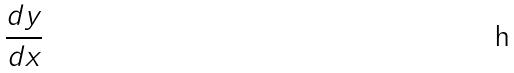<formula> <loc_0><loc_0><loc_500><loc_500>\frac { d y } { d x }</formula> 